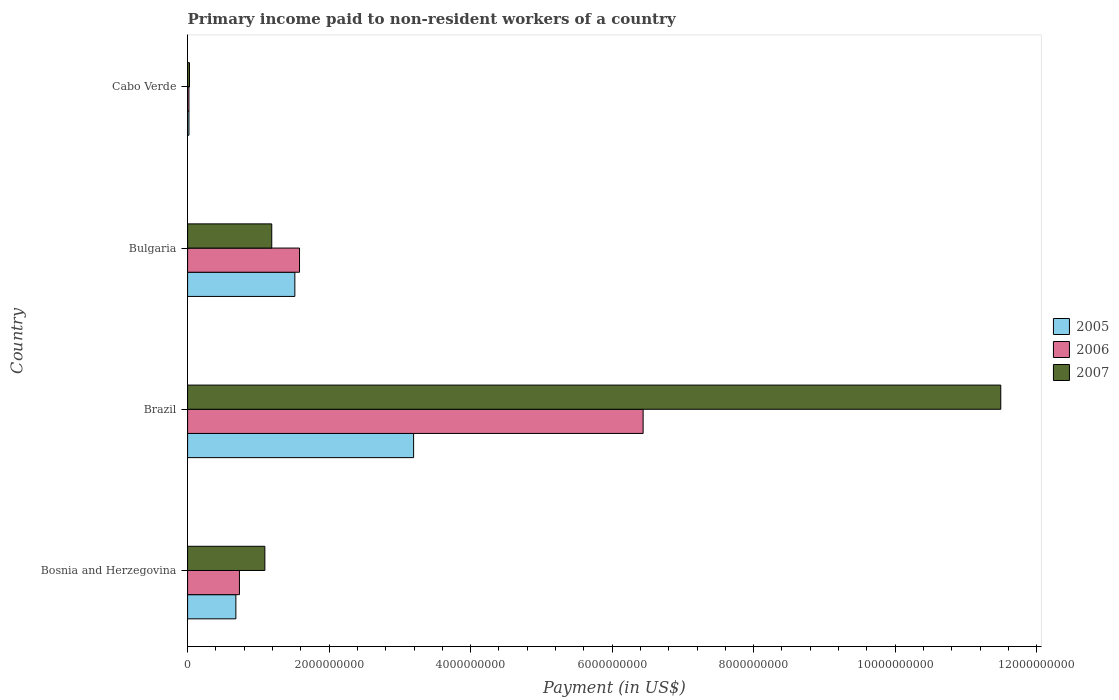How many different coloured bars are there?
Keep it short and to the point. 3. Are the number of bars per tick equal to the number of legend labels?
Your answer should be compact. Yes. Are the number of bars on each tick of the Y-axis equal?
Keep it short and to the point. Yes. How many bars are there on the 3rd tick from the bottom?
Keep it short and to the point. 3. What is the label of the 4th group of bars from the top?
Your answer should be very brief. Bosnia and Herzegovina. In how many cases, is the number of bars for a given country not equal to the number of legend labels?
Offer a terse response. 0. What is the amount paid to workers in 2007 in Brazil?
Offer a very short reply. 1.15e+1. Across all countries, what is the maximum amount paid to workers in 2007?
Provide a succinct answer. 1.15e+1. Across all countries, what is the minimum amount paid to workers in 2006?
Ensure brevity in your answer.  1.91e+07. In which country was the amount paid to workers in 2007 minimum?
Ensure brevity in your answer.  Cabo Verde. What is the total amount paid to workers in 2005 in the graph?
Keep it short and to the point. 5.41e+09. What is the difference between the amount paid to workers in 2006 in Bosnia and Herzegovina and that in Bulgaria?
Provide a short and direct response. -8.49e+08. What is the difference between the amount paid to workers in 2005 in Brazil and the amount paid to workers in 2006 in Cabo Verde?
Your answer should be compact. 3.18e+09. What is the average amount paid to workers in 2006 per country?
Make the answer very short. 2.19e+09. What is the difference between the amount paid to workers in 2006 and amount paid to workers in 2005 in Bulgaria?
Offer a very short reply. 6.60e+07. In how many countries, is the amount paid to workers in 2006 greater than 9600000000 US$?
Provide a short and direct response. 0. What is the ratio of the amount paid to workers in 2005 in Bosnia and Herzegovina to that in Brazil?
Offer a very short reply. 0.21. Is the amount paid to workers in 2005 in Bosnia and Herzegovina less than that in Bulgaria?
Provide a succinct answer. Yes. Is the difference between the amount paid to workers in 2006 in Bulgaria and Cabo Verde greater than the difference between the amount paid to workers in 2005 in Bulgaria and Cabo Verde?
Make the answer very short. Yes. What is the difference between the highest and the second highest amount paid to workers in 2005?
Your answer should be very brief. 1.68e+09. What is the difference between the highest and the lowest amount paid to workers in 2005?
Your answer should be very brief. 3.18e+09. Is the sum of the amount paid to workers in 2007 in Bosnia and Herzegovina and Brazil greater than the maximum amount paid to workers in 2005 across all countries?
Your response must be concise. Yes. Is it the case that in every country, the sum of the amount paid to workers in 2005 and amount paid to workers in 2007 is greater than the amount paid to workers in 2006?
Give a very brief answer. Yes. How many countries are there in the graph?
Make the answer very short. 4. What is the difference between two consecutive major ticks on the X-axis?
Your answer should be compact. 2.00e+09. Does the graph contain any zero values?
Offer a terse response. No. How many legend labels are there?
Provide a short and direct response. 3. What is the title of the graph?
Make the answer very short. Primary income paid to non-resident workers of a country. Does "1992" appear as one of the legend labels in the graph?
Offer a very short reply. No. What is the label or title of the X-axis?
Offer a very short reply. Payment (in US$). What is the Payment (in US$) of 2005 in Bosnia and Herzegovina?
Ensure brevity in your answer.  6.82e+08. What is the Payment (in US$) in 2006 in Bosnia and Herzegovina?
Provide a succinct answer. 7.33e+08. What is the Payment (in US$) of 2007 in Bosnia and Herzegovina?
Your answer should be very brief. 1.09e+09. What is the Payment (in US$) of 2005 in Brazil?
Give a very brief answer. 3.19e+09. What is the Payment (in US$) in 2006 in Brazil?
Your answer should be very brief. 6.44e+09. What is the Payment (in US$) in 2007 in Brazil?
Your answer should be very brief. 1.15e+1. What is the Payment (in US$) of 2005 in Bulgaria?
Make the answer very short. 1.52e+09. What is the Payment (in US$) in 2006 in Bulgaria?
Make the answer very short. 1.58e+09. What is the Payment (in US$) of 2007 in Bulgaria?
Offer a terse response. 1.19e+09. What is the Payment (in US$) of 2005 in Cabo Verde?
Provide a short and direct response. 1.92e+07. What is the Payment (in US$) in 2006 in Cabo Verde?
Give a very brief answer. 1.91e+07. What is the Payment (in US$) in 2007 in Cabo Verde?
Offer a terse response. 2.67e+07. Across all countries, what is the maximum Payment (in US$) of 2005?
Provide a succinct answer. 3.19e+09. Across all countries, what is the maximum Payment (in US$) in 2006?
Provide a short and direct response. 6.44e+09. Across all countries, what is the maximum Payment (in US$) in 2007?
Ensure brevity in your answer.  1.15e+1. Across all countries, what is the minimum Payment (in US$) in 2005?
Ensure brevity in your answer.  1.92e+07. Across all countries, what is the minimum Payment (in US$) in 2006?
Make the answer very short. 1.91e+07. Across all countries, what is the minimum Payment (in US$) in 2007?
Offer a terse response. 2.67e+07. What is the total Payment (in US$) in 2005 in the graph?
Make the answer very short. 5.41e+09. What is the total Payment (in US$) in 2006 in the graph?
Give a very brief answer. 8.77e+09. What is the total Payment (in US$) of 2007 in the graph?
Give a very brief answer. 1.38e+1. What is the difference between the Payment (in US$) of 2005 in Bosnia and Herzegovina and that in Brazil?
Your answer should be very brief. -2.51e+09. What is the difference between the Payment (in US$) of 2006 in Bosnia and Herzegovina and that in Brazil?
Your answer should be very brief. -5.71e+09. What is the difference between the Payment (in US$) of 2007 in Bosnia and Herzegovina and that in Brazil?
Make the answer very short. -1.04e+1. What is the difference between the Payment (in US$) of 2005 in Bosnia and Herzegovina and that in Bulgaria?
Your response must be concise. -8.33e+08. What is the difference between the Payment (in US$) of 2006 in Bosnia and Herzegovina and that in Bulgaria?
Keep it short and to the point. -8.49e+08. What is the difference between the Payment (in US$) in 2007 in Bosnia and Herzegovina and that in Bulgaria?
Offer a terse response. -9.75e+07. What is the difference between the Payment (in US$) in 2005 in Bosnia and Herzegovina and that in Cabo Verde?
Your answer should be compact. 6.63e+08. What is the difference between the Payment (in US$) of 2006 in Bosnia and Herzegovina and that in Cabo Verde?
Your response must be concise. 7.14e+08. What is the difference between the Payment (in US$) in 2007 in Bosnia and Herzegovina and that in Cabo Verde?
Your answer should be very brief. 1.07e+09. What is the difference between the Payment (in US$) in 2005 in Brazil and that in Bulgaria?
Your answer should be very brief. 1.68e+09. What is the difference between the Payment (in US$) in 2006 in Brazil and that in Bulgaria?
Provide a succinct answer. 4.86e+09. What is the difference between the Payment (in US$) of 2007 in Brazil and that in Bulgaria?
Offer a terse response. 1.03e+1. What is the difference between the Payment (in US$) in 2005 in Brazil and that in Cabo Verde?
Make the answer very short. 3.18e+09. What is the difference between the Payment (in US$) of 2006 in Brazil and that in Cabo Verde?
Provide a succinct answer. 6.42e+09. What is the difference between the Payment (in US$) of 2007 in Brazil and that in Cabo Verde?
Offer a terse response. 1.15e+1. What is the difference between the Payment (in US$) of 2005 in Bulgaria and that in Cabo Verde?
Provide a short and direct response. 1.50e+09. What is the difference between the Payment (in US$) of 2006 in Bulgaria and that in Cabo Verde?
Ensure brevity in your answer.  1.56e+09. What is the difference between the Payment (in US$) in 2007 in Bulgaria and that in Cabo Verde?
Your answer should be very brief. 1.16e+09. What is the difference between the Payment (in US$) in 2005 in Bosnia and Herzegovina and the Payment (in US$) in 2006 in Brazil?
Keep it short and to the point. -5.76e+09. What is the difference between the Payment (in US$) in 2005 in Bosnia and Herzegovina and the Payment (in US$) in 2007 in Brazil?
Your answer should be very brief. -1.08e+1. What is the difference between the Payment (in US$) of 2006 in Bosnia and Herzegovina and the Payment (in US$) of 2007 in Brazil?
Offer a terse response. -1.08e+1. What is the difference between the Payment (in US$) in 2005 in Bosnia and Herzegovina and the Payment (in US$) in 2006 in Bulgaria?
Provide a short and direct response. -8.99e+08. What is the difference between the Payment (in US$) in 2005 in Bosnia and Herzegovina and the Payment (in US$) in 2007 in Bulgaria?
Your response must be concise. -5.07e+08. What is the difference between the Payment (in US$) in 2006 in Bosnia and Herzegovina and the Payment (in US$) in 2007 in Bulgaria?
Provide a short and direct response. -4.57e+08. What is the difference between the Payment (in US$) of 2005 in Bosnia and Herzegovina and the Payment (in US$) of 2006 in Cabo Verde?
Keep it short and to the point. 6.63e+08. What is the difference between the Payment (in US$) in 2005 in Bosnia and Herzegovina and the Payment (in US$) in 2007 in Cabo Verde?
Keep it short and to the point. 6.56e+08. What is the difference between the Payment (in US$) of 2006 in Bosnia and Herzegovina and the Payment (in US$) of 2007 in Cabo Verde?
Provide a short and direct response. 7.06e+08. What is the difference between the Payment (in US$) in 2005 in Brazil and the Payment (in US$) in 2006 in Bulgaria?
Ensure brevity in your answer.  1.61e+09. What is the difference between the Payment (in US$) of 2005 in Brazil and the Payment (in US$) of 2007 in Bulgaria?
Ensure brevity in your answer.  2.00e+09. What is the difference between the Payment (in US$) in 2006 in Brazil and the Payment (in US$) in 2007 in Bulgaria?
Provide a short and direct response. 5.25e+09. What is the difference between the Payment (in US$) in 2005 in Brazil and the Payment (in US$) in 2006 in Cabo Verde?
Ensure brevity in your answer.  3.18e+09. What is the difference between the Payment (in US$) of 2005 in Brazil and the Payment (in US$) of 2007 in Cabo Verde?
Offer a very short reply. 3.17e+09. What is the difference between the Payment (in US$) of 2006 in Brazil and the Payment (in US$) of 2007 in Cabo Verde?
Your answer should be very brief. 6.41e+09. What is the difference between the Payment (in US$) in 2005 in Bulgaria and the Payment (in US$) in 2006 in Cabo Verde?
Your answer should be very brief. 1.50e+09. What is the difference between the Payment (in US$) of 2005 in Bulgaria and the Payment (in US$) of 2007 in Cabo Verde?
Give a very brief answer. 1.49e+09. What is the difference between the Payment (in US$) of 2006 in Bulgaria and the Payment (in US$) of 2007 in Cabo Verde?
Provide a short and direct response. 1.55e+09. What is the average Payment (in US$) of 2005 per country?
Your response must be concise. 1.35e+09. What is the average Payment (in US$) in 2006 per country?
Your answer should be very brief. 2.19e+09. What is the average Payment (in US$) in 2007 per country?
Your response must be concise. 3.45e+09. What is the difference between the Payment (in US$) in 2005 and Payment (in US$) in 2006 in Bosnia and Herzegovina?
Provide a succinct answer. -5.03e+07. What is the difference between the Payment (in US$) in 2005 and Payment (in US$) in 2007 in Bosnia and Herzegovina?
Ensure brevity in your answer.  -4.10e+08. What is the difference between the Payment (in US$) in 2006 and Payment (in US$) in 2007 in Bosnia and Herzegovina?
Offer a terse response. -3.59e+08. What is the difference between the Payment (in US$) in 2005 and Payment (in US$) in 2006 in Brazil?
Ensure brevity in your answer.  -3.24e+09. What is the difference between the Payment (in US$) of 2005 and Payment (in US$) of 2007 in Brazil?
Your answer should be very brief. -8.30e+09. What is the difference between the Payment (in US$) in 2006 and Payment (in US$) in 2007 in Brazil?
Make the answer very short. -5.05e+09. What is the difference between the Payment (in US$) in 2005 and Payment (in US$) in 2006 in Bulgaria?
Your response must be concise. -6.60e+07. What is the difference between the Payment (in US$) of 2005 and Payment (in US$) of 2007 in Bulgaria?
Your answer should be compact. 3.26e+08. What is the difference between the Payment (in US$) of 2006 and Payment (in US$) of 2007 in Bulgaria?
Give a very brief answer. 3.92e+08. What is the difference between the Payment (in US$) in 2005 and Payment (in US$) in 2006 in Cabo Verde?
Make the answer very short. 1.54e+05. What is the difference between the Payment (in US$) in 2005 and Payment (in US$) in 2007 in Cabo Verde?
Offer a very short reply. -7.50e+06. What is the difference between the Payment (in US$) in 2006 and Payment (in US$) in 2007 in Cabo Verde?
Provide a short and direct response. -7.66e+06. What is the ratio of the Payment (in US$) of 2005 in Bosnia and Herzegovina to that in Brazil?
Offer a terse response. 0.21. What is the ratio of the Payment (in US$) of 2006 in Bosnia and Herzegovina to that in Brazil?
Ensure brevity in your answer.  0.11. What is the ratio of the Payment (in US$) in 2007 in Bosnia and Herzegovina to that in Brazil?
Ensure brevity in your answer.  0.1. What is the ratio of the Payment (in US$) in 2005 in Bosnia and Herzegovina to that in Bulgaria?
Provide a succinct answer. 0.45. What is the ratio of the Payment (in US$) of 2006 in Bosnia and Herzegovina to that in Bulgaria?
Your response must be concise. 0.46. What is the ratio of the Payment (in US$) in 2007 in Bosnia and Herzegovina to that in Bulgaria?
Provide a succinct answer. 0.92. What is the ratio of the Payment (in US$) of 2005 in Bosnia and Herzegovina to that in Cabo Verde?
Offer a terse response. 35.49. What is the ratio of the Payment (in US$) in 2006 in Bosnia and Herzegovina to that in Cabo Verde?
Your answer should be very brief. 38.41. What is the ratio of the Payment (in US$) in 2007 in Bosnia and Herzegovina to that in Cabo Verde?
Your answer should be compact. 40.85. What is the ratio of the Payment (in US$) in 2005 in Brazil to that in Bulgaria?
Offer a very short reply. 2.11. What is the ratio of the Payment (in US$) in 2006 in Brazil to that in Bulgaria?
Keep it short and to the point. 4.07. What is the ratio of the Payment (in US$) in 2007 in Brazil to that in Bulgaria?
Provide a short and direct response. 9.66. What is the ratio of the Payment (in US$) of 2005 in Brazil to that in Cabo Verde?
Offer a terse response. 166.14. What is the ratio of the Payment (in US$) in 2006 in Brazil to that in Cabo Verde?
Provide a succinct answer. 337.55. What is the ratio of the Payment (in US$) of 2007 in Brazil to that in Cabo Verde?
Your response must be concise. 429.95. What is the ratio of the Payment (in US$) in 2005 in Bulgaria to that in Cabo Verde?
Offer a terse response. 78.83. What is the ratio of the Payment (in US$) of 2006 in Bulgaria to that in Cabo Verde?
Offer a very short reply. 82.93. What is the ratio of the Payment (in US$) in 2007 in Bulgaria to that in Cabo Verde?
Keep it short and to the point. 44.5. What is the difference between the highest and the second highest Payment (in US$) of 2005?
Ensure brevity in your answer.  1.68e+09. What is the difference between the highest and the second highest Payment (in US$) in 2006?
Offer a very short reply. 4.86e+09. What is the difference between the highest and the second highest Payment (in US$) of 2007?
Make the answer very short. 1.03e+1. What is the difference between the highest and the lowest Payment (in US$) of 2005?
Give a very brief answer. 3.18e+09. What is the difference between the highest and the lowest Payment (in US$) of 2006?
Provide a succinct answer. 6.42e+09. What is the difference between the highest and the lowest Payment (in US$) in 2007?
Your answer should be compact. 1.15e+1. 